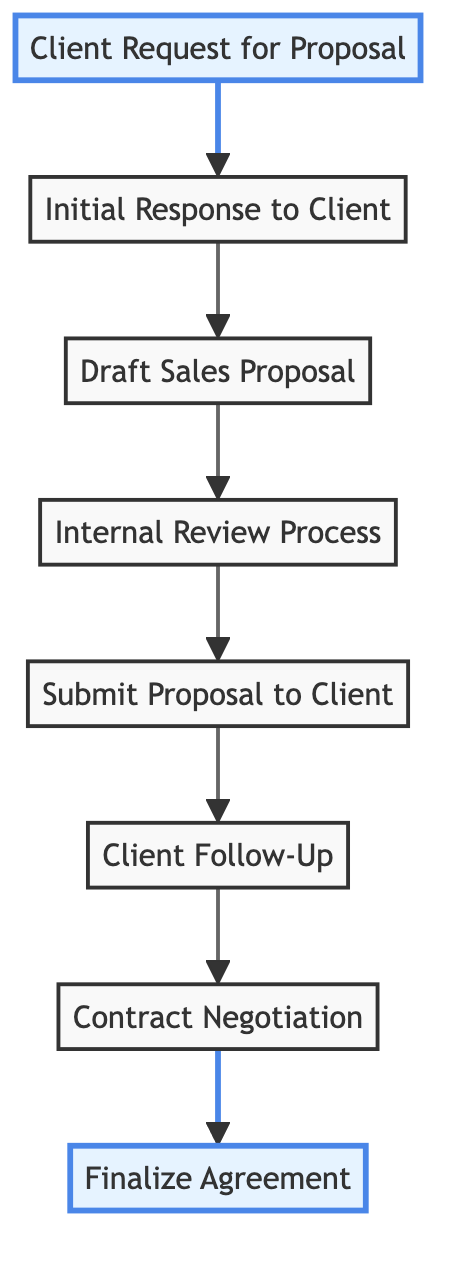What is the first step in the workflow? The first step in the workflow is represented by the node labeled "Client Request for Proposal". It is the starting point, as indicated by its position in the diagram with arrows flowing out to the next node.
Answer: Client Request for Proposal How many nodes are present in the diagram? The diagram contains eight nodes, which can be counted by identifying each distinct label: Client Request for Proposal, Initial Response to Client, Draft Sales Proposal, Internal Review Process, Submit Proposal to Client, Client Follow-Up, Contract Negotiation, and Finalize Agreement.
Answer: 8 What node comes after the "Proposal Drafting"? After "Proposal Drafting", the next node in the flow is "Internal Review Process", as represented by the arrow leading from the "Draft Sales Proposal" node to the "Internal Review Process" node in the directed graph.
Answer: Internal Review Process Which node leads to the "Finalization"? The "Contract Negotiation" node leads to "Finalization". This is determined by the edge connecting these two nodes, with "Contract Negotiation" as the source and "Finalize Agreement" as the target.
Answer: Contract Negotiation What is the total number of edges in the diagram? There are seven edges in the diagram, which can be identified by counting the arrows connecting the nodes: from Client Request to Initial Response, Initial Response to Proposal Drafting, Proposal Drafting to Review Process, Review Process to Proposal Submission, Proposal Submission to Follow Up, Follow Up to Contract Negotiation, and finally, Contract Negotiation to Finalization.
Answer: 7 What is the relationship between "Client Follow-Up" and "Contract Negotiation"? The relationship is that "Client Follow-Up" flows directly into "Contract Negotiation". This means that once the follow-up with the client takes place, it leads to the negotiation of the contract as shown by the directed edge in the diagram.
Answer: Leads to Which nodes are highlighted in the diagram? The nodes highlighted in the diagram are "Client Request for Proposal" and "Finalize Agreement". This is indicated by their distinct color presentation, setting them apart from the other nodes.
Answer: Client Request for Proposal, Finalize Agreement What step follows "Submit Proposal to Client"? The step that follows "Submit Proposal to Client" is "Client Follow-Up". This can be observed in the diagram as there is an arrow connecting the "Submit Proposal to Client" node to the "Client Follow-Up" node, indicating the sequence of actions in the workflow.
Answer: Client Follow-Up 